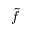<formula> <loc_0><loc_0><loc_500><loc_500>\tilde { f }</formula> 